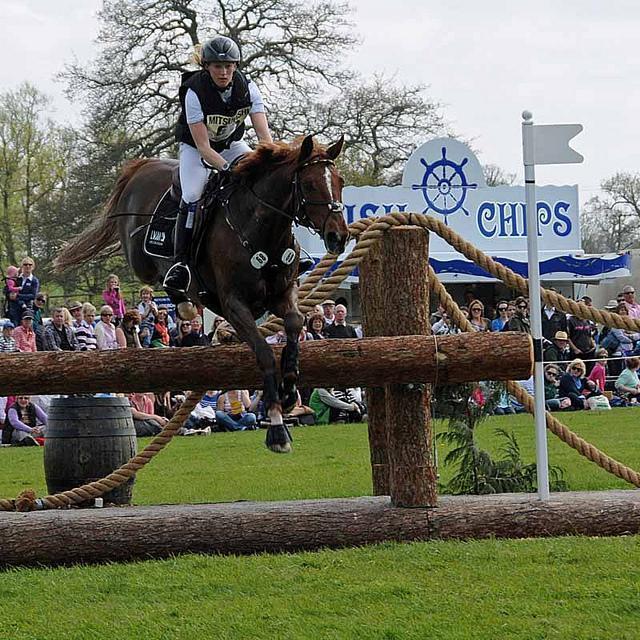How many people are there?
Give a very brief answer. 2. 